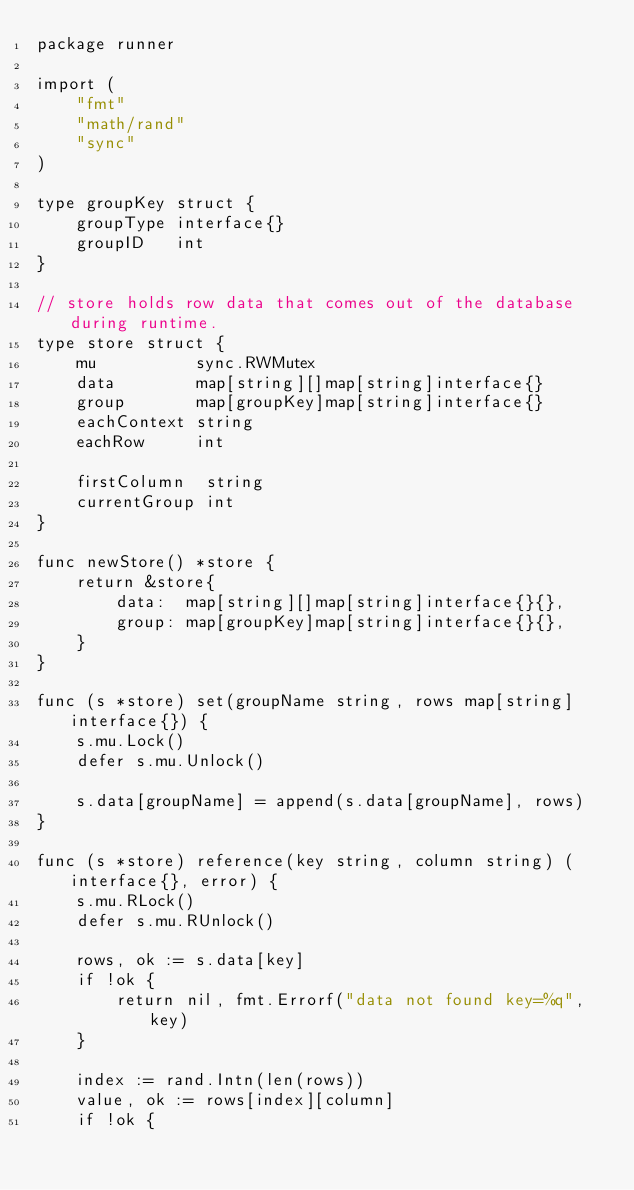Convert code to text. <code><loc_0><loc_0><loc_500><loc_500><_Go_>package runner

import (
	"fmt"
	"math/rand"
	"sync"
)

type groupKey struct {
	groupType interface{}
	groupID   int
}

// store holds row data that comes out of the database during runtime.
type store struct {
	mu          sync.RWMutex
	data        map[string][]map[string]interface{}
	group       map[groupKey]map[string]interface{}
	eachContext string
	eachRow     int

	firstColumn  string
	currentGroup int
}

func newStore() *store {
	return &store{
		data:  map[string][]map[string]interface{}{},
		group: map[groupKey]map[string]interface{}{},
	}
}

func (s *store) set(groupName string, rows map[string]interface{}) {
	s.mu.Lock()
	defer s.mu.Unlock()

	s.data[groupName] = append(s.data[groupName], rows)
}

func (s *store) reference(key string, column string) (interface{}, error) {
	s.mu.RLock()
	defer s.mu.RUnlock()

	rows, ok := s.data[key]
	if !ok {
		return nil, fmt.Errorf("data not found key=%q", key)
	}

	index := rand.Intn(len(rows))
	value, ok := rows[index][column]
	if !ok {</code> 